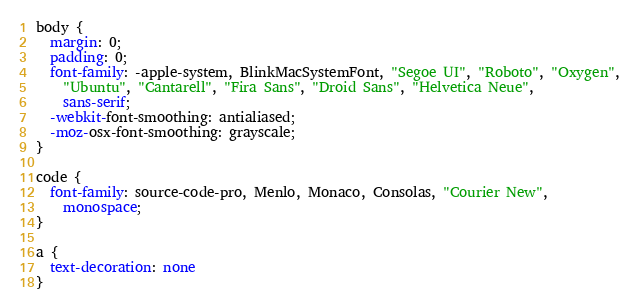Convert code to text. <code><loc_0><loc_0><loc_500><loc_500><_CSS_>body {
  margin: 0;
  padding: 0;
  font-family: -apple-system, BlinkMacSystemFont, "Segoe UI", "Roboto", "Oxygen",
    "Ubuntu", "Cantarell", "Fira Sans", "Droid Sans", "Helvetica Neue",
    sans-serif;
  -webkit-font-smoothing: antialiased;
  -moz-osx-font-smoothing: grayscale;
}

code {
  font-family: source-code-pro, Menlo, Monaco, Consolas, "Courier New",
    monospace;
}

a {
  text-decoration: none
}
</code> 